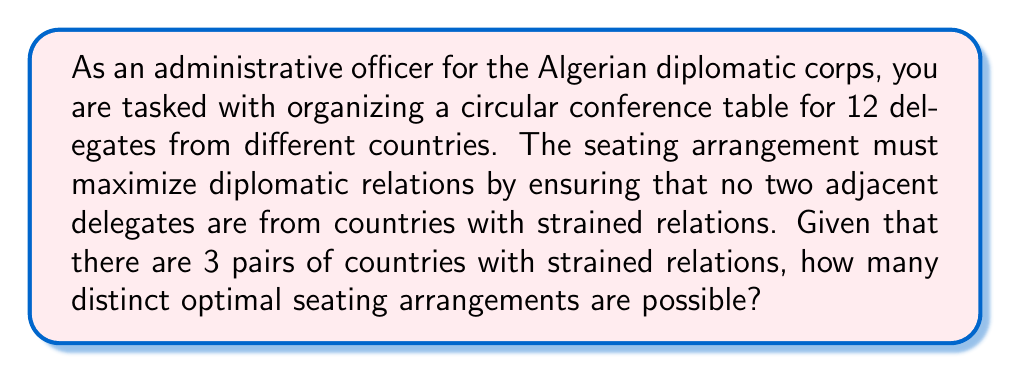Can you answer this question? Let's approach this step-by-step:

1) First, we need to understand that this is a problem of circular permutations with restrictions.

2) In a circular arrangement, we can fix one delegate's position and arrange the rest. So we effectively have 11! permutations to start with.

3) However, we need to account for the restriction of the 3 pairs of countries with strained relations. This is equivalent to finding the number of permutations where these 3 pairs are never adjacent.

4) To solve this, we can use the Principle of Inclusion-Exclusion (PIE).

5) Let $A_i$ be the set of arrangements where the $i$-th pair of countries with strained relations are adjacent.

6) We want to find $|A_1^c \cap A_2^c \cap A_3^c|$, where $A_i^c$ is the complement of $A_i$.

7) By PIE: 
   $$|A_1^c \cap A_2^c \cap A_3^c| = N - (|A_1| + |A_2| + |A_3|) + (|A_1 \cap A_2| + |A_1 \cap A_3| + |A_2 \cap A_3|) - |A_1 \cap A_2 \cap A_3|$$

8) Where $N$ is the total number of circular permutations: $N = 11!$

9) $|A_i| = 10!$ for each $i$, because if we consider each pair as a single unit, we have 11 units to arrange circularly.

10) $|A_i \cap A_j| = 9!$ for each pair $(i,j)$, as we now have two pairs fixed as units.

11) $|A_1 \cap A_2 \cap A_3| = 8!$, as all three pairs are now fixed as units.

12) Substituting these values:
    $$|A_1^c \cap A_2^c \cap A_3^c| = 11! - 3(10!) + 3(9!) - 8!$$

13) Calculating:
    $$|A_1^c \cap A_2^c \cap A_3^c| = 39,916,800 - 10,886,400 + 1,088,640 - 40,320 = 30,078,720$$

Therefore, there are 30,078,720 distinct optimal seating arrangements.
Answer: 30,078,720 distinct optimal seating arrangements 